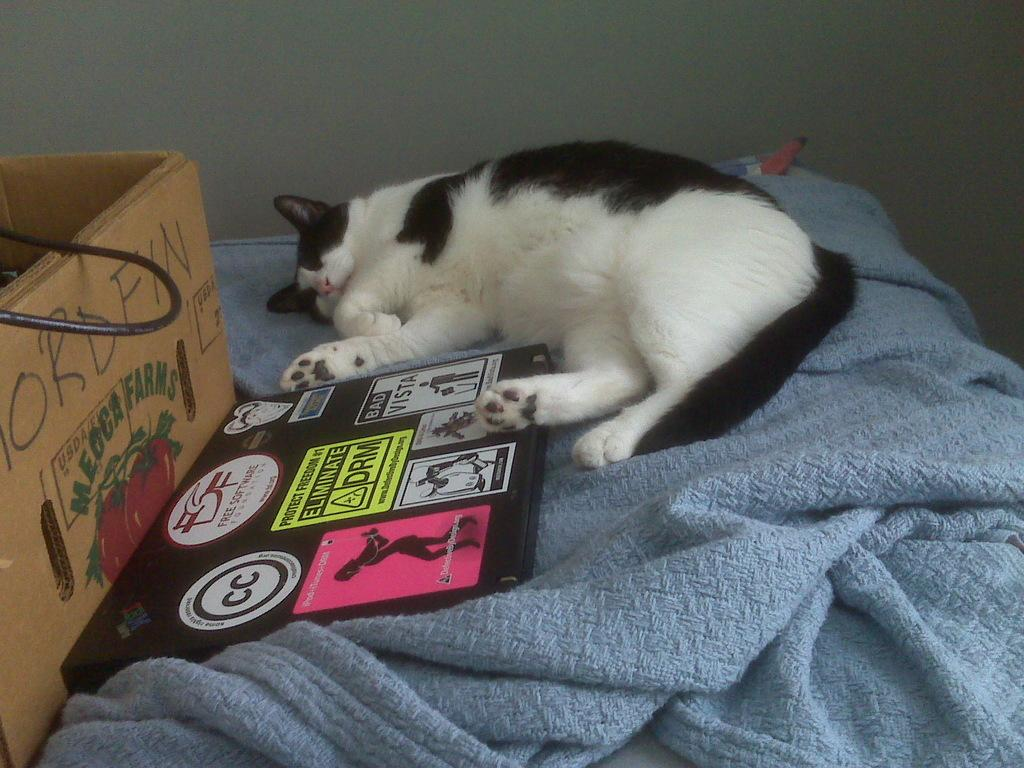<image>
Share a concise interpretation of the image provided. A cat lays next to a laptop and box from Mecca Farms. 